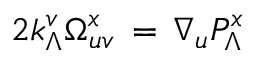Convert formula to latex. <formula><loc_0><loc_0><loc_500><loc_500>2 k _ { \Lambda } ^ { v } \Omega _ { u v } ^ { x } \, = \, \nabla _ { u } P _ { \Lambda } ^ { x }</formula> 